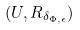Convert formula to latex. <formula><loc_0><loc_0><loc_500><loc_500>( U , R _ { \delta _ { \Phi , \epsilon } } )</formula> 